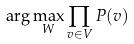Convert formula to latex. <formula><loc_0><loc_0><loc_500><loc_500>\arg \max _ { W } \prod _ { v \in V } P ( v )</formula> 